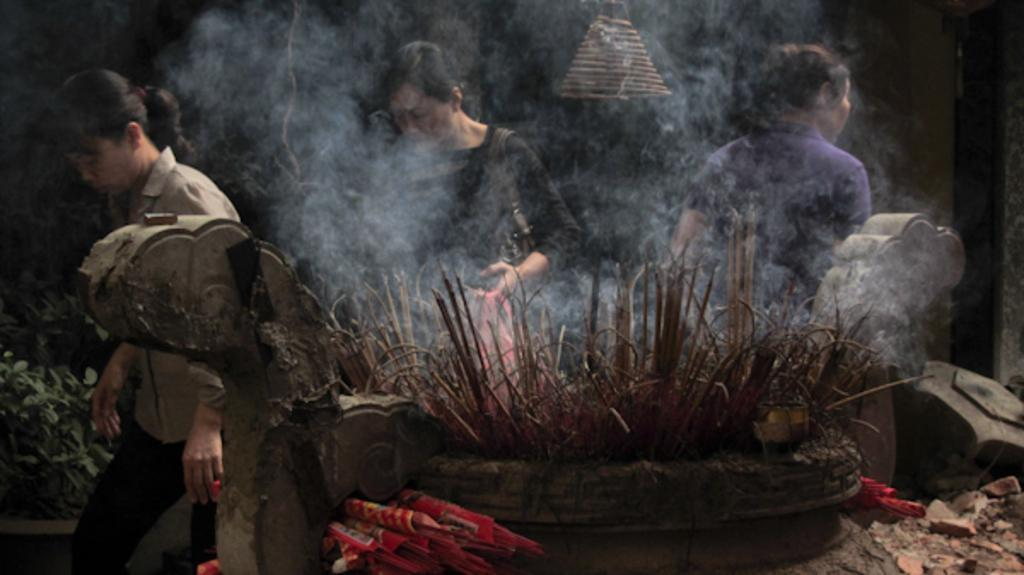How many people are in the image? There are three persons in the image. What is the main feature in the image? There is a fountain in the image. What is unusual about the fountain? Dry leaves and smoke are present in the fountain. What can be seen to the left of the image? There are plants to the left of the image. What is the color of the background in the image? The background of the image is black in color. What type of box is being used for the trip in the image? There is no box or trip present in the image; it features three persons and a fountain with dry leaves and smoke. 